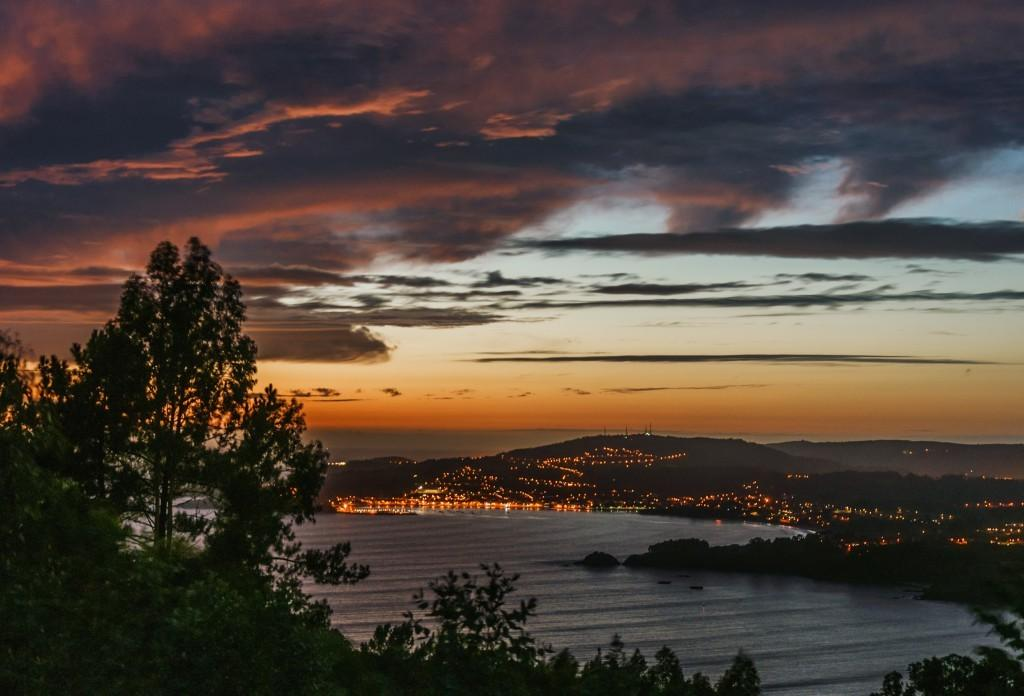What type of illumination can be seen in the image? There are lights in the image. What type of vegetation is present in the image? There are plants and trees in the image. What natural feature is visible in the image? The ocean is visible in the image. What part of the natural environment is visible in the image? The sky is visible in the image. What type of hammer is being used to pickle the sign in the image? There is no hammer, pickle, or sign present in the image. 